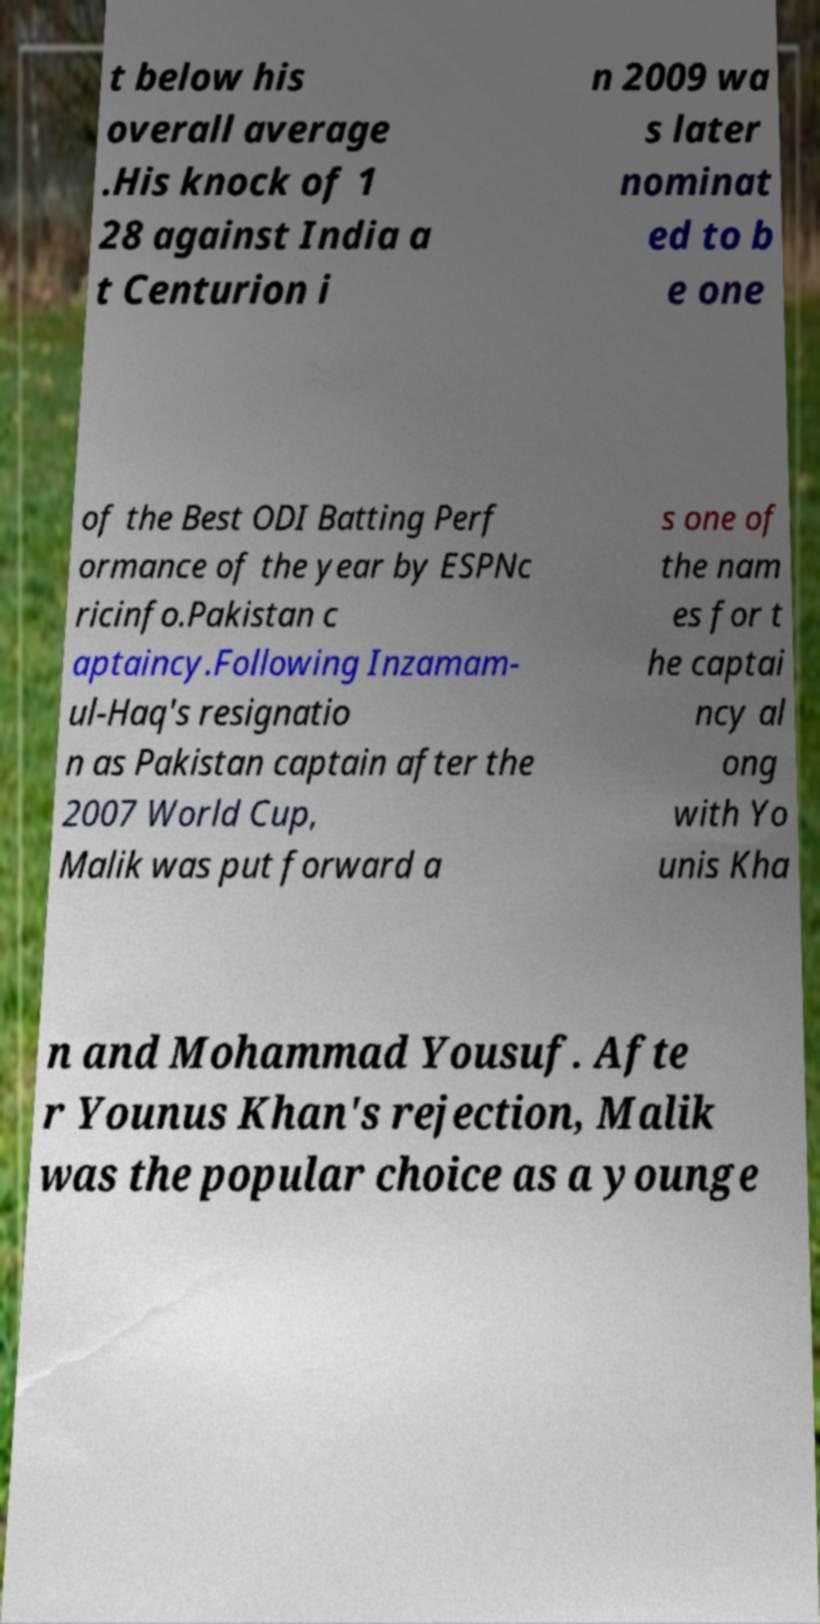I need the written content from this picture converted into text. Can you do that? t below his overall average .His knock of 1 28 against India a t Centurion i n 2009 wa s later nominat ed to b e one of the Best ODI Batting Perf ormance of the year by ESPNc ricinfo.Pakistan c aptaincy.Following Inzamam- ul-Haq's resignatio n as Pakistan captain after the 2007 World Cup, Malik was put forward a s one of the nam es for t he captai ncy al ong with Yo unis Kha n and Mohammad Yousuf. Afte r Younus Khan's rejection, Malik was the popular choice as a younge 